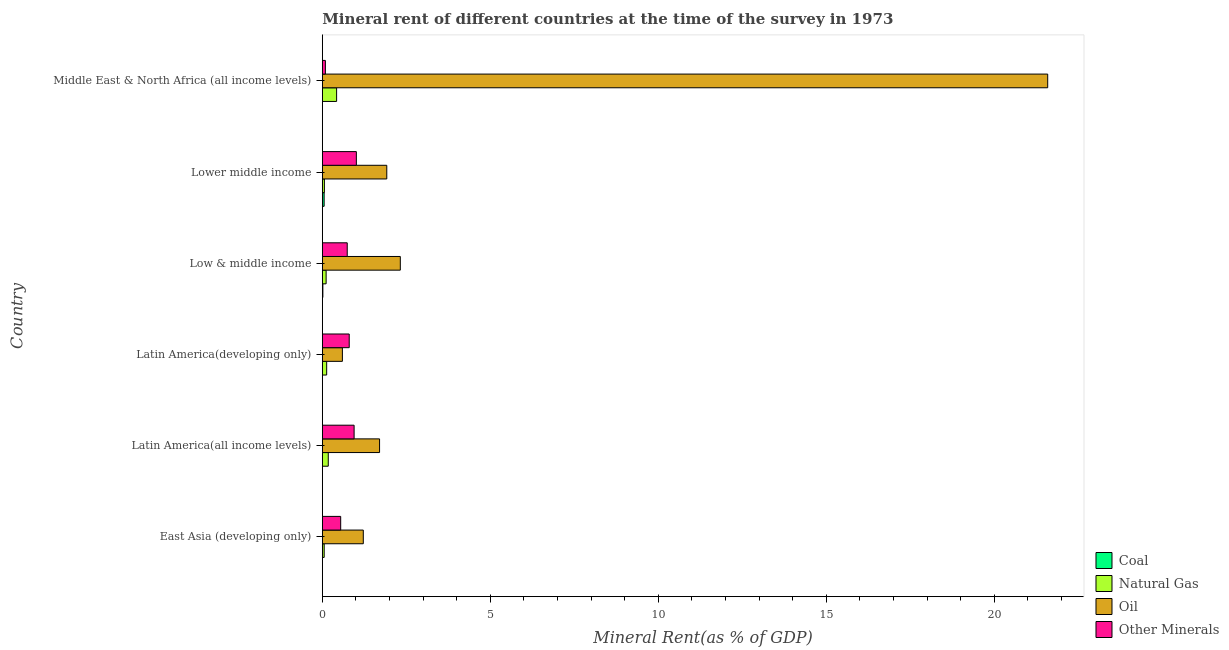How many different coloured bars are there?
Ensure brevity in your answer.  4. How many groups of bars are there?
Your answer should be very brief. 6. How many bars are there on the 3rd tick from the top?
Your response must be concise. 4. What is the label of the 5th group of bars from the top?
Provide a short and direct response. Latin America(all income levels). What is the natural gas rent in Low & middle income?
Your answer should be very brief. 0.11. Across all countries, what is the maximum coal rent?
Ensure brevity in your answer.  0.05. Across all countries, what is the minimum natural gas rent?
Your answer should be very brief. 0.06. In which country was the natural gas rent maximum?
Your answer should be very brief. Middle East & North Africa (all income levels). In which country was the  rent of other minerals minimum?
Offer a terse response. Middle East & North Africa (all income levels). What is the total oil rent in the graph?
Offer a very short reply. 29.35. What is the difference between the coal rent in Latin America(all income levels) and that in Low & middle income?
Offer a terse response. -0.02. What is the difference between the  rent of other minerals in Latin America(developing only) and the natural gas rent in Latin America(all income levels)?
Your answer should be very brief. 0.62. What is the average oil rent per country?
Your answer should be compact. 4.89. What is the difference between the coal rent and  rent of other minerals in Lower middle income?
Make the answer very short. -0.96. What is the ratio of the  rent of other minerals in East Asia (developing only) to that in Lower middle income?
Your answer should be compact. 0.54. Is the natural gas rent in Latin America(developing only) less than that in Lower middle income?
Offer a terse response. No. What is the difference between the highest and the second highest  rent of other minerals?
Keep it short and to the point. 0.07. What is the difference between the highest and the lowest oil rent?
Your answer should be compact. 20.99. Is the sum of the natural gas rent in Latin America(all income levels) and Middle East & North Africa (all income levels) greater than the maximum  rent of other minerals across all countries?
Your answer should be compact. No. Is it the case that in every country, the sum of the coal rent and natural gas rent is greater than the sum of  rent of other minerals and oil rent?
Your answer should be compact. No. What does the 3rd bar from the top in Middle East & North Africa (all income levels) represents?
Ensure brevity in your answer.  Natural Gas. What does the 2nd bar from the bottom in Low & middle income represents?
Provide a succinct answer. Natural Gas. Is it the case that in every country, the sum of the coal rent and natural gas rent is greater than the oil rent?
Give a very brief answer. No. How many bars are there?
Ensure brevity in your answer.  24. Are all the bars in the graph horizontal?
Make the answer very short. Yes. What is the difference between two consecutive major ticks on the X-axis?
Ensure brevity in your answer.  5. Does the graph contain any zero values?
Offer a terse response. No. Where does the legend appear in the graph?
Offer a very short reply. Bottom right. How many legend labels are there?
Offer a very short reply. 4. How are the legend labels stacked?
Offer a very short reply. Vertical. What is the title of the graph?
Offer a terse response. Mineral rent of different countries at the time of the survey in 1973. Does "Korea" appear as one of the legend labels in the graph?
Your answer should be very brief. No. What is the label or title of the X-axis?
Offer a terse response. Mineral Rent(as % of GDP). What is the Mineral Rent(as % of GDP) in Coal in East Asia (developing only)?
Offer a very short reply. 0. What is the Mineral Rent(as % of GDP) of Natural Gas in East Asia (developing only)?
Provide a short and direct response. 0.06. What is the Mineral Rent(as % of GDP) of Oil in East Asia (developing only)?
Your response must be concise. 1.22. What is the Mineral Rent(as % of GDP) in Other Minerals in East Asia (developing only)?
Give a very brief answer. 0.55. What is the Mineral Rent(as % of GDP) in Coal in Latin America(all income levels)?
Give a very brief answer. 1.897656593667769e-5. What is the Mineral Rent(as % of GDP) in Natural Gas in Latin America(all income levels)?
Make the answer very short. 0.18. What is the Mineral Rent(as % of GDP) of Oil in Latin America(all income levels)?
Ensure brevity in your answer.  1.7. What is the Mineral Rent(as % of GDP) in Other Minerals in Latin America(all income levels)?
Provide a short and direct response. 0.95. What is the Mineral Rent(as % of GDP) in Coal in Latin America(developing only)?
Offer a terse response. 2.93770621847752e-5. What is the Mineral Rent(as % of GDP) in Natural Gas in Latin America(developing only)?
Provide a short and direct response. 0.13. What is the Mineral Rent(as % of GDP) of Oil in Latin America(developing only)?
Your answer should be compact. 0.6. What is the Mineral Rent(as % of GDP) in Other Minerals in Latin America(developing only)?
Provide a succinct answer. 0.8. What is the Mineral Rent(as % of GDP) in Coal in Low & middle income?
Make the answer very short. 0.02. What is the Mineral Rent(as % of GDP) of Natural Gas in Low & middle income?
Your answer should be compact. 0.11. What is the Mineral Rent(as % of GDP) of Oil in Low & middle income?
Make the answer very short. 2.32. What is the Mineral Rent(as % of GDP) of Other Minerals in Low & middle income?
Ensure brevity in your answer.  0.74. What is the Mineral Rent(as % of GDP) of Coal in Lower middle income?
Provide a succinct answer. 0.05. What is the Mineral Rent(as % of GDP) of Natural Gas in Lower middle income?
Make the answer very short. 0.06. What is the Mineral Rent(as % of GDP) of Oil in Lower middle income?
Your answer should be compact. 1.92. What is the Mineral Rent(as % of GDP) in Other Minerals in Lower middle income?
Your answer should be very brief. 1.01. What is the Mineral Rent(as % of GDP) in Coal in Middle East & North Africa (all income levels)?
Make the answer very short. 0. What is the Mineral Rent(as % of GDP) in Natural Gas in Middle East & North Africa (all income levels)?
Ensure brevity in your answer.  0.43. What is the Mineral Rent(as % of GDP) in Oil in Middle East & North Africa (all income levels)?
Keep it short and to the point. 21.59. What is the Mineral Rent(as % of GDP) of Other Minerals in Middle East & North Africa (all income levels)?
Provide a succinct answer. 0.09. Across all countries, what is the maximum Mineral Rent(as % of GDP) in Coal?
Make the answer very short. 0.05. Across all countries, what is the maximum Mineral Rent(as % of GDP) in Natural Gas?
Your answer should be very brief. 0.43. Across all countries, what is the maximum Mineral Rent(as % of GDP) of Oil?
Offer a very short reply. 21.59. Across all countries, what is the maximum Mineral Rent(as % of GDP) of Other Minerals?
Your answer should be very brief. 1.01. Across all countries, what is the minimum Mineral Rent(as % of GDP) in Coal?
Offer a very short reply. 1.897656593667769e-5. Across all countries, what is the minimum Mineral Rent(as % of GDP) in Natural Gas?
Ensure brevity in your answer.  0.06. Across all countries, what is the minimum Mineral Rent(as % of GDP) in Oil?
Offer a very short reply. 0.6. Across all countries, what is the minimum Mineral Rent(as % of GDP) in Other Minerals?
Your answer should be very brief. 0.09. What is the total Mineral Rent(as % of GDP) of Coal in the graph?
Make the answer very short. 0.07. What is the total Mineral Rent(as % of GDP) of Natural Gas in the graph?
Offer a terse response. 0.96. What is the total Mineral Rent(as % of GDP) of Oil in the graph?
Your response must be concise. 29.35. What is the total Mineral Rent(as % of GDP) of Other Minerals in the graph?
Ensure brevity in your answer.  4.14. What is the difference between the Mineral Rent(as % of GDP) in Natural Gas in East Asia (developing only) and that in Latin America(all income levels)?
Your response must be concise. -0.12. What is the difference between the Mineral Rent(as % of GDP) in Oil in East Asia (developing only) and that in Latin America(all income levels)?
Your response must be concise. -0.48. What is the difference between the Mineral Rent(as % of GDP) in Other Minerals in East Asia (developing only) and that in Latin America(all income levels)?
Ensure brevity in your answer.  -0.4. What is the difference between the Mineral Rent(as % of GDP) of Coal in East Asia (developing only) and that in Latin America(developing only)?
Ensure brevity in your answer.  0. What is the difference between the Mineral Rent(as % of GDP) in Natural Gas in East Asia (developing only) and that in Latin America(developing only)?
Provide a succinct answer. -0.07. What is the difference between the Mineral Rent(as % of GDP) in Oil in East Asia (developing only) and that in Latin America(developing only)?
Your response must be concise. 0.62. What is the difference between the Mineral Rent(as % of GDP) in Other Minerals in East Asia (developing only) and that in Latin America(developing only)?
Offer a terse response. -0.25. What is the difference between the Mineral Rent(as % of GDP) of Coal in East Asia (developing only) and that in Low & middle income?
Make the answer very short. -0.02. What is the difference between the Mineral Rent(as % of GDP) in Natural Gas in East Asia (developing only) and that in Low & middle income?
Offer a terse response. -0.06. What is the difference between the Mineral Rent(as % of GDP) in Oil in East Asia (developing only) and that in Low & middle income?
Your response must be concise. -1.1. What is the difference between the Mineral Rent(as % of GDP) of Other Minerals in East Asia (developing only) and that in Low & middle income?
Your answer should be very brief. -0.19. What is the difference between the Mineral Rent(as % of GDP) of Coal in East Asia (developing only) and that in Lower middle income?
Your response must be concise. -0.05. What is the difference between the Mineral Rent(as % of GDP) of Natural Gas in East Asia (developing only) and that in Lower middle income?
Keep it short and to the point. -0.01. What is the difference between the Mineral Rent(as % of GDP) in Oil in East Asia (developing only) and that in Lower middle income?
Your answer should be compact. -0.7. What is the difference between the Mineral Rent(as % of GDP) in Other Minerals in East Asia (developing only) and that in Lower middle income?
Your answer should be compact. -0.47. What is the difference between the Mineral Rent(as % of GDP) of Coal in East Asia (developing only) and that in Middle East & North Africa (all income levels)?
Your response must be concise. -0. What is the difference between the Mineral Rent(as % of GDP) in Natural Gas in East Asia (developing only) and that in Middle East & North Africa (all income levels)?
Keep it short and to the point. -0.37. What is the difference between the Mineral Rent(as % of GDP) in Oil in East Asia (developing only) and that in Middle East & North Africa (all income levels)?
Offer a very short reply. -20.37. What is the difference between the Mineral Rent(as % of GDP) in Other Minerals in East Asia (developing only) and that in Middle East & North Africa (all income levels)?
Your response must be concise. 0.46. What is the difference between the Mineral Rent(as % of GDP) in Coal in Latin America(all income levels) and that in Latin America(developing only)?
Your response must be concise. -0. What is the difference between the Mineral Rent(as % of GDP) of Natural Gas in Latin America(all income levels) and that in Latin America(developing only)?
Give a very brief answer. 0.05. What is the difference between the Mineral Rent(as % of GDP) of Oil in Latin America(all income levels) and that in Latin America(developing only)?
Provide a succinct answer. 1.11. What is the difference between the Mineral Rent(as % of GDP) in Other Minerals in Latin America(all income levels) and that in Latin America(developing only)?
Ensure brevity in your answer.  0.15. What is the difference between the Mineral Rent(as % of GDP) in Coal in Latin America(all income levels) and that in Low & middle income?
Your answer should be compact. -0.02. What is the difference between the Mineral Rent(as % of GDP) in Natural Gas in Latin America(all income levels) and that in Low & middle income?
Ensure brevity in your answer.  0.06. What is the difference between the Mineral Rent(as % of GDP) of Oil in Latin America(all income levels) and that in Low & middle income?
Your answer should be compact. -0.62. What is the difference between the Mineral Rent(as % of GDP) in Other Minerals in Latin America(all income levels) and that in Low & middle income?
Offer a terse response. 0.2. What is the difference between the Mineral Rent(as % of GDP) of Coal in Latin America(all income levels) and that in Lower middle income?
Provide a short and direct response. -0.05. What is the difference between the Mineral Rent(as % of GDP) of Natural Gas in Latin America(all income levels) and that in Lower middle income?
Offer a very short reply. 0.12. What is the difference between the Mineral Rent(as % of GDP) of Oil in Latin America(all income levels) and that in Lower middle income?
Your response must be concise. -0.21. What is the difference between the Mineral Rent(as % of GDP) of Other Minerals in Latin America(all income levels) and that in Lower middle income?
Give a very brief answer. -0.07. What is the difference between the Mineral Rent(as % of GDP) of Coal in Latin America(all income levels) and that in Middle East & North Africa (all income levels)?
Offer a very short reply. -0. What is the difference between the Mineral Rent(as % of GDP) in Natural Gas in Latin America(all income levels) and that in Middle East & North Africa (all income levels)?
Ensure brevity in your answer.  -0.25. What is the difference between the Mineral Rent(as % of GDP) of Oil in Latin America(all income levels) and that in Middle East & North Africa (all income levels)?
Offer a very short reply. -19.89. What is the difference between the Mineral Rent(as % of GDP) in Other Minerals in Latin America(all income levels) and that in Middle East & North Africa (all income levels)?
Offer a terse response. 0.85. What is the difference between the Mineral Rent(as % of GDP) of Coal in Latin America(developing only) and that in Low & middle income?
Your response must be concise. -0.02. What is the difference between the Mineral Rent(as % of GDP) in Natural Gas in Latin America(developing only) and that in Low & middle income?
Offer a very short reply. 0.02. What is the difference between the Mineral Rent(as % of GDP) of Oil in Latin America(developing only) and that in Low & middle income?
Your answer should be very brief. -1.72. What is the difference between the Mineral Rent(as % of GDP) in Other Minerals in Latin America(developing only) and that in Low & middle income?
Give a very brief answer. 0.06. What is the difference between the Mineral Rent(as % of GDP) of Coal in Latin America(developing only) and that in Lower middle income?
Make the answer very short. -0.05. What is the difference between the Mineral Rent(as % of GDP) of Natural Gas in Latin America(developing only) and that in Lower middle income?
Your answer should be compact. 0.07. What is the difference between the Mineral Rent(as % of GDP) of Oil in Latin America(developing only) and that in Lower middle income?
Your answer should be very brief. -1.32. What is the difference between the Mineral Rent(as % of GDP) of Other Minerals in Latin America(developing only) and that in Lower middle income?
Offer a terse response. -0.21. What is the difference between the Mineral Rent(as % of GDP) in Coal in Latin America(developing only) and that in Middle East & North Africa (all income levels)?
Offer a terse response. -0. What is the difference between the Mineral Rent(as % of GDP) in Natural Gas in Latin America(developing only) and that in Middle East & North Africa (all income levels)?
Your response must be concise. -0.3. What is the difference between the Mineral Rent(as % of GDP) in Oil in Latin America(developing only) and that in Middle East & North Africa (all income levels)?
Keep it short and to the point. -20.99. What is the difference between the Mineral Rent(as % of GDP) of Other Minerals in Latin America(developing only) and that in Middle East & North Africa (all income levels)?
Offer a terse response. 0.71. What is the difference between the Mineral Rent(as % of GDP) of Coal in Low & middle income and that in Lower middle income?
Make the answer very short. -0.04. What is the difference between the Mineral Rent(as % of GDP) of Natural Gas in Low & middle income and that in Lower middle income?
Offer a very short reply. 0.05. What is the difference between the Mineral Rent(as % of GDP) in Oil in Low & middle income and that in Lower middle income?
Your response must be concise. 0.4. What is the difference between the Mineral Rent(as % of GDP) of Other Minerals in Low & middle income and that in Lower middle income?
Provide a short and direct response. -0.27. What is the difference between the Mineral Rent(as % of GDP) in Coal in Low & middle income and that in Middle East & North Africa (all income levels)?
Keep it short and to the point. 0.01. What is the difference between the Mineral Rent(as % of GDP) of Natural Gas in Low & middle income and that in Middle East & North Africa (all income levels)?
Provide a succinct answer. -0.31. What is the difference between the Mineral Rent(as % of GDP) of Oil in Low & middle income and that in Middle East & North Africa (all income levels)?
Ensure brevity in your answer.  -19.27. What is the difference between the Mineral Rent(as % of GDP) of Other Minerals in Low & middle income and that in Middle East & North Africa (all income levels)?
Ensure brevity in your answer.  0.65. What is the difference between the Mineral Rent(as % of GDP) of Coal in Lower middle income and that in Middle East & North Africa (all income levels)?
Your answer should be very brief. 0.05. What is the difference between the Mineral Rent(as % of GDP) in Natural Gas in Lower middle income and that in Middle East & North Africa (all income levels)?
Your response must be concise. -0.36. What is the difference between the Mineral Rent(as % of GDP) of Oil in Lower middle income and that in Middle East & North Africa (all income levels)?
Offer a terse response. -19.67. What is the difference between the Mineral Rent(as % of GDP) in Other Minerals in Lower middle income and that in Middle East & North Africa (all income levels)?
Offer a very short reply. 0.92. What is the difference between the Mineral Rent(as % of GDP) in Coal in East Asia (developing only) and the Mineral Rent(as % of GDP) in Natural Gas in Latin America(all income levels)?
Keep it short and to the point. -0.18. What is the difference between the Mineral Rent(as % of GDP) in Coal in East Asia (developing only) and the Mineral Rent(as % of GDP) in Oil in Latin America(all income levels)?
Make the answer very short. -1.7. What is the difference between the Mineral Rent(as % of GDP) in Coal in East Asia (developing only) and the Mineral Rent(as % of GDP) in Other Minerals in Latin America(all income levels)?
Give a very brief answer. -0.95. What is the difference between the Mineral Rent(as % of GDP) in Natural Gas in East Asia (developing only) and the Mineral Rent(as % of GDP) in Oil in Latin America(all income levels)?
Make the answer very short. -1.65. What is the difference between the Mineral Rent(as % of GDP) of Natural Gas in East Asia (developing only) and the Mineral Rent(as % of GDP) of Other Minerals in Latin America(all income levels)?
Offer a very short reply. -0.89. What is the difference between the Mineral Rent(as % of GDP) of Oil in East Asia (developing only) and the Mineral Rent(as % of GDP) of Other Minerals in Latin America(all income levels)?
Give a very brief answer. 0.27. What is the difference between the Mineral Rent(as % of GDP) in Coal in East Asia (developing only) and the Mineral Rent(as % of GDP) in Natural Gas in Latin America(developing only)?
Give a very brief answer. -0.13. What is the difference between the Mineral Rent(as % of GDP) of Coal in East Asia (developing only) and the Mineral Rent(as % of GDP) of Oil in Latin America(developing only)?
Keep it short and to the point. -0.6. What is the difference between the Mineral Rent(as % of GDP) in Coal in East Asia (developing only) and the Mineral Rent(as % of GDP) in Other Minerals in Latin America(developing only)?
Provide a succinct answer. -0.8. What is the difference between the Mineral Rent(as % of GDP) in Natural Gas in East Asia (developing only) and the Mineral Rent(as % of GDP) in Oil in Latin America(developing only)?
Offer a very short reply. -0.54. What is the difference between the Mineral Rent(as % of GDP) of Natural Gas in East Asia (developing only) and the Mineral Rent(as % of GDP) of Other Minerals in Latin America(developing only)?
Your answer should be compact. -0.74. What is the difference between the Mineral Rent(as % of GDP) in Oil in East Asia (developing only) and the Mineral Rent(as % of GDP) in Other Minerals in Latin America(developing only)?
Keep it short and to the point. 0.42. What is the difference between the Mineral Rent(as % of GDP) of Coal in East Asia (developing only) and the Mineral Rent(as % of GDP) of Natural Gas in Low & middle income?
Your answer should be very brief. -0.11. What is the difference between the Mineral Rent(as % of GDP) in Coal in East Asia (developing only) and the Mineral Rent(as % of GDP) in Oil in Low & middle income?
Provide a succinct answer. -2.32. What is the difference between the Mineral Rent(as % of GDP) of Coal in East Asia (developing only) and the Mineral Rent(as % of GDP) of Other Minerals in Low & middle income?
Ensure brevity in your answer.  -0.74. What is the difference between the Mineral Rent(as % of GDP) in Natural Gas in East Asia (developing only) and the Mineral Rent(as % of GDP) in Oil in Low & middle income?
Give a very brief answer. -2.27. What is the difference between the Mineral Rent(as % of GDP) of Natural Gas in East Asia (developing only) and the Mineral Rent(as % of GDP) of Other Minerals in Low & middle income?
Provide a short and direct response. -0.69. What is the difference between the Mineral Rent(as % of GDP) in Oil in East Asia (developing only) and the Mineral Rent(as % of GDP) in Other Minerals in Low & middle income?
Your answer should be compact. 0.48. What is the difference between the Mineral Rent(as % of GDP) of Coal in East Asia (developing only) and the Mineral Rent(as % of GDP) of Natural Gas in Lower middle income?
Your answer should be compact. -0.06. What is the difference between the Mineral Rent(as % of GDP) of Coal in East Asia (developing only) and the Mineral Rent(as % of GDP) of Oil in Lower middle income?
Your answer should be compact. -1.92. What is the difference between the Mineral Rent(as % of GDP) in Coal in East Asia (developing only) and the Mineral Rent(as % of GDP) in Other Minerals in Lower middle income?
Offer a terse response. -1.01. What is the difference between the Mineral Rent(as % of GDP) of Natural Gas in East Asia (developing only) and the Mineral Rent(as % of GDP) of Oil in Lower middle income?
Offer a terse response. -1.86. What is the difference between the Mineral Rent(as % of GDP) in Natural Gas in East Asia (developing only) and the Mineral Rent(as % of GDP) in Other Minerals in Lower middle income?
Provide a succinct answer. -0.96. What is the difference between the Mineral Rent(as % of GDP) of Oil in East Asia (developing only) and the Mineral Rent(as % of GDP) of Other Minerals in Lower middle income?
Your answer should be very brief. 0.21. What is the difference between the Mineral Rent(as % of GDP) of Coal in East Asia (developing only) and the Mineral Rent(as % of GDP) of Natural Gas in Middle East & North Africa (all income levels)?
Give a very brief answer. -0.42. What is the difference between the Mineral Rent(as % of GDP) of Coal in East Asia (developing only) and the Mineral Rent(as % of GDP) of Oil in Middle East & North Africa (all income levels)?
Provide a short and direct response. -21.59. What is the difference between the Mineral Rent(as % of GDP) in Coal in East Asia (developing only) and the Mineral Rent(as % of GDP) in Other Minerals in Middle East & North Africa (all income levels)?
Your answer should be compact. -0.09. What is the difference between the Mineral Rent(as % of GDP) of Natural Gas in East Asia (developing only) and the Mineral Rent(as % of GDP) of Oil in Middle East & North Africa (all income levels)?
Keep it short and to the point. -21.53. What is the difference between the Mineral Rent(as % of GDP) of Natural Gas in East Asia (developing only) and the Mineral Rent(as % of GDP) of Other Minerals in Middle East & North Africa (all income levels)?
Provide a short and direct response. -0.04. What is the difference between the Mineral Rent(as % of GDP) in Oil in East Asia (developing only) and the Mineral Rent(as % of GDP) in Other Minerals in Middle East & North Africa (all income levels)?
Provide a succinct answer. 1.13. What is the difference between the Mineral Rent(as % of GDP) in Coal in Latin America(all income levels) and the Mineral Rent(as % of GDP) in Natural Gas in Latin America(developing only)?
Give a very brief answer. -0.13. What is the difference between the Mineral Rent(as % of GDP) of Coal in Latin America(all income levels) and the Mineral Rent(as % of GDP) of Oil in Latin America(developing only)?
Offer a very short reply. -0.6. What is the difference between the Mineral Rent(as % of GDP) in Coal in Latin America(all income levels) and the Mineral Rent(as % of GDP) in Other Minerals in Latin America(developing only)?
Make the answer very short. -0.8. What is the difference between the Mineral Rent(as % of GDP) of Natural Gas in Latin America(all income levels) and the Mineral Rent(as % of GDP) of Oil in Latin America(developing only)?
Your response must be concise. -0.42. What is the difference between the Mineral Rent(as % of GDP) of Natural Gas in Latin America(all income levels) and the Mineral Rent(as % of GDP) of Other Minerals in Latin America(developing only)?
Offer a very short reply. -0.62. What is the difference between the Mineral Rent(as % of GDP) of Oil in Latin America(all income levels) and the Mineral Rent(as % of GDP) of Other Minerals in Latin America(developing only)?
Offer a very short reply. 0.9. What is the difference between the Mineral Rent(as % of GDP) in Coal in Latin America(all income levels) and the Mineral Rent(as % of GDP) in Natural Gas in Low & middle income?
Offer a terse response. -0.11. What is the difference between the Mineral Rent(as % of GDP) of Coal in Latin America(all income levels) and the Mineral Rent(as % of GDP) of Oil in Low & middle income?
Provide a short and direct response. -2.32. What is the difference between the Mineral Rent(as % of GDP) in Coal in Latin America(all income levels) and the Mineral Rent(as % of GDP) in Other Minerals in Low & middle income?
Make the answer very short. -0.74. What is the difference between the Mineral Rent(as % of GDP) of Natural Gas in Latin America(all income levels) and the Mineral Rent(as % of GDP) of Oil in Low & middle income?
Keep it short and to the point. -2.14. What is the difference between the Mineral Rent(as % of GDP) of Natural Gas in Latin America(all income levels) and the Mineral Rent(as % of GDP) of Other Minerals in Low & middle income?
Offer a very short reply. -0.56. What is the difference between the Mineral Rent(as % of GDP) in Oil in Latin America(all income levels) and the Mineral Rent(as % of GDP) in Other Minerals in Low & middle income?
Your answer should be very brief. 0.96. What is the difference between the Mineral Rent(as % of GDP) of Coal in Latin America(all income levels) and the Mineral Rent(as % of GDP) of Natural Gas in Lower middle income?
Offer a terse response. -0.06. What is the difference between the Mineral Rent(as % of GDP) of Coal in Latin America(all income levels) and the Mineral Rent(as % of GDP) of Oil in Lower middle income?
Keep it short and to the point. -1.92. What is the difference between the Mineral Rent(as % of GDP) in Coal in Latin America(all income levels) and the Mineral Rent(as % of GDP) in Other Minerals in Lower middle income?
Keep it short and to the point. -1.01. What is the difference between the Mineral Rent(as % of GDP) of Natural Gas in Latin America(all income levels) and the Mineral Rent(as % of GDP) of Oil in Lower middle income?
Provide a succinct answer. -1.74. What is the difference between the Mineral Rent(as % of GDP) in Natural Gas in Latin America(all income levels) and the Mineral Rent(as % of GDP) in Other Minerals in Lower middle income?
Offer a very short reply. -0.84. What is the difference between the Mineral Rent(as % of GDP) of Oil in Latin America(all income levels) and the Mineral Rent(as % of GDP) of Other Minerals in Lower middle income?
Your answer should be compact. 0.69. What is the difference between the Mineral Rent(as % of GDP) in Coal in Latin America(all income levels) and the Mineral Rent(as % of GDP) in Natural Gas in Middle East & North Africa (all income levels)?
Offer a terse response. -0.42. What is the difference between the Mineral Rent(as % of GDP) in Coal in Latin America(all income levels) and the Mineral Rent(as % of GDP) in Oil in Middle East & North Africa (all income levels)?
Offer a terse response. -21.59. What is the difference between the Mineral Rent(as % of GDP) in Coal in Latin America(all income levels) and the Mineral Rent(as % of GDP) in Other Minerals in Middle East & North Africa (all income levels)?
Your answer should be compact. -0.09. What is the difference between the Mineral Rent(as % of GDP) of Natural Gas in Latin America(all income levels) and the Mineral Rent(as % of GDP) of Oil in Middle East & North Africa (all income levels)?
Provide a short and direct response. -21.41. What is the difference between the Mineral Rent(as % of GDP) in Natural Gas in Latin America(all income levels) and the Mineral Rent(as % of GDP) in Other Minerals in Middle East & North Africa (all income levels)?
Make the answer very short. 0.09. What is the difference between the Mineral Rent(as % of GDP) of Oil in Latin America(all income levels) and the Mineral Rent(as % of GDP) of Other Minerals in Middle East & North Africa (all income levels)?
Make the answer very short. 1.61. What is the difference between the Mineral Rent(as % of GDP) of Coal in Latin America(developing only) and the Mineral Rent(as % of GDP) of Natural Gas in Low & middle income?
Your response must be concise. -0.11. What is the difference between the Mineral Rent(as % of GDP) in Coal in Latin America(developing only) and the Mineral Rent(as % of GDP) in Oil in Low & middle income?
Offer a terse response. -2.32. What is the difference between the Mineral Rent(as % of GDP) in Coal in Latin America(developing only) and the Mineral Rent(as % of GDP) in Other Minerals in Low & middle income?
Provide a succinct answer. -0.74. What is the difference between the Mineral Rent(as % of GDP) of Natural Gas in Latin America(developing only) and the Mineral Rent(as % of GDP) of Oil in Low & middle income?
Keep it short and to the point. -2.19. What is the difference between the Mineral Rent(as % of GDP) of Natural Gas in Latin America(developing only) and the Mineral Rent(as % of GDP) of Other Minerals in Low & middle income?
Your answer should be very brief. -0.61. What is the difference between the Mineral Rent(as % of GDP) in Oil in Latin America(developing only) and the Mineral Rent(as % of GDP) in Other Minerals in Low & middle income?
Provide a succinct answer. -0.14. What is the difference between the Mineral Rent(as % of GDP) of Coal in Latin America(developing only) and the Mineral Rent(as % of GDP) of Natural Gas in Lower middle income?
Ensure brevity in your answer.  -0.06. What is the difference between the Mineral Rent(as % of GDP) of Coal in Latin America(developing only) and the Mineral Rent(as % of GDP) of Oil in Lower middle income?
Your answer should be compact. -1.92. What is the difference between the Mineral Rent(as % of GDP) of Coal in Latin America(developing only) and the Mineral Rent(as % of GDP) of Other Minerals in Lower middle income?
Make the answer very short. -1.01. What is the difference between the Mineral Rent(as % of GDP) in Natural Gas in Latin America(developing only) and the Mineral Rent(as % of GDP) in Oil in Lower middle income?
Your answer should be very brief. -1.79. What is the difference between the Mineral Rent(as % of GDP) in Natural Gas in Latin America(developing only) and the Mineral Rent(as % of GDP) in Other Minerals in Lower middle income?
Give a very brief answer. -0.88. What is the difference between the Mineral Rent(as % of GDP) in Oil in Latin America(developing only) and the Mineral Rent(as % of GDP) in Other Minerals in Lower middle income?
Make the answer very short. -0.42. What is the difference between the Mineral Rent(as % of GDP) in Coal in Latin America(developing only) and the Mineral Rent(as % of GDP) in Natural Gas in Middle East & North Africa (all income levels)?
Keep it short and to the point. -0.42. What is the difference between the Mineral Rent(as % of GDP) of Coal in Latin America(developing only) and the Mineral Rent(as % of GDP) of Oil in Middle East & North Africa (all income levels)?
Provide a short and direct response. -21.59. What is the difference between the Mineral Rent(as % of GDP) in Coal in Latin America(developing only) and the Mineral Rent(as % of GDP) in Other Minerals in Middle East & North Africa (all income levels)?
Your response must be concise. -0.09. What is the difference between the Mineral Rent(as % of GDP) of Natural Gas in Latin America(developing only) and the Mineral Rent(as % of GDP) of Oil in Middle East & North Africa (all income levels)?
Your answer should be very brief. -21.46. What is the difference between the Mineral Rent(as % of GDP) in Natural Gas in Latin America(developing only) and the Mineral Rent(as % of GDP) in Other Minerals in Middle East & North Africa (all income levels)?
Your answer should be compact. 0.04. What is the difference between the Mineral Rent(as % of GDP) in Oil in Latin America(developing only) and the Mineral Rent(as % of GDP) in Other Minerals in Middle East & North Africa (all income levels)?
Your answer should be compact. 0.51. What is the difference between the Mineral Rent(as % of GDP) in Coal in Low & middle income and the Mineral Rent(as % of GDP) in Natural Gas in Lower middle income?
Ensure brevity in your answer.  -0.05. What is the difference between the Mineral Rent(as % of GDP) in Coal in Low & middle income and the Mineral Rent(as % of GDP) in Oil in Lower middle income?
Your answer should be very brief. -1.9. What is the difference between the Mineral Rent(as % of GDP) of Coal in Low & middle income and the Mineral Rent(as % of GDP) of Other Minerals in Lower middle income?
Keep it short and to the point. -1. What is the difference between the Mineral Rent(as % of GDP) in Natural Gas in Low & middle income and the Mineral Rent(as % of GDP) in Oil in Lower middle income?
Ensure brevity in your answer.  -1.81. What is the difference between the Mineral Rent(as % of GDP) in Natural Gas in Low & middle income and the Mineral Rent(as % of GDP) in Other Minerals in Lower middle income?
Provide a short and direct response. -0.9. What is the difference between the Mineral Rent(as % of GDP) in Oil in Low & middle income and the Mineral Rent(as % of GDP) in Other Minerals in Lower middle income?
Ensure brevity in your answer.  1.31. What is the difference between the Mineral Rent(as % of GDP) in Coal in Low & middle income and the Mineral Rent(as % of GDP) in Natural Gas in Middle East & North Africa (all income levels)?
Keep it short and to the point. -0.41. What is the difference between the Mineral Rent(as % of GDP) in Coal in Low & middle income and the Mineral Rent(as % of GDP) in Oil in Middle East & North Africa (all income levels)?
Keep it short and to the point. -21.57. What is the difference between the Mineral Rent(as % of GDP) in Coal in Low & middle income and the Mineral Rent(as % of GDP) in Other Minerals in Middle East & North Africa (all income levels)?
Offer a terse response. -0.07. What is the difference between the Mineral Rent(as % of GDP) of Natural Gas in Low & middle income and the Mineral Rent(as % of GDP) of Oil in Middle East & North Africa (all income levels)?
Provide a short and direct response. -21.48. What is the difference between the Mineral Rent(as % of GDP) in Natural Gas in Low & middle income and the Mineral Rent(as % of GDP) in Other Minerals in Middle East & North Africa (all income levels)?
Offer a terse response. 0.02. What is the difference between the Mineral Rent(as % of GDP) of Oil in Low & middle income and the Mineral Rent(as % of GDP) of Other Minerals in Middle East & North Africa (all income levels)?
Offer a terse response. 2.23. What is the difference between the Mineral Rent(as % of GDP) in Coal in Lower middle income and the Mineral Rent(as % of GDP) in Natural Gas in Middle East & North Africa (all income levels)?
Your answer should be compact. -0.37. What is the difference between the Mineral Rent(as % of GDP) of Coal in Lower middle income and the Mineral Rent(as % of GDP) of Oil in Middle East & North Africa (all income levels)?
Keep it short and to the point. -21.54. What is the difference between the Mineral Rent(as % of GDP) of Coal in Lower middle income and the Mineral Rent(as % of GDP) of Other Minerals in Middle East & North Africa (all income levels)?
Keep it short and to the point. -0.04. What is the difference between the Mineral Rent(as % of GDP) of Natural Gas in Lower middle income and the Mineral Rent(as % of GDP) of Oil in Middle East & North Africa (all income levels)?
Keep it short and to the point. -21.53. What is the difference between the Mineral Rent(as % of GDP) in Natural Gas in Lower middle income and the Mineral Rent(as % of GDP) in Other Minerals in Middle East & North Africa (all income levels)?
Give a very brief answer. -0.03. What is the difference between the Mineral Rent(as % of GDP) of Oil in Lower middle income and the Mineral Rent(as % of GDP) of Other Minerals in Middle East & North Africa (all income levels)?
Your response must be concise. 1.83. What is the average Mineral Rent(as % of GDP) in Coal per country?
Offer a very short reply. 0.01. What is the average Mineral Rent(as % of GDP) of Natural Gas per country?
Offer a very short reply. 0.16. What is the average Mineral Rent(as % of GDP) of Oil per country?
Your answer should be compact. 4.89. What is the average Mineral Rent(as % of GDP) of Other Minerals per country?
Provide a short and direct response. 0.69. What is the difference between the Mineral Rent(as % of GDP) of Coal and Mineral Rent(as % of GDP) of Natural Gas in East Asia (developing only)?
Your answer should be very brief. -0.06. What is the difference between the Mineral Rent(as % of GDP) of Coal and Mineral Rent(as % of GDP) of Oil in East Asia (developing only)?
Keep it short and to the point. -1.22. What is the difference between the Mineral Rent(as % of GDP) in Coal and Mineral Rent(as % of GDP) in Other Minerals in East Asia (developing only)?
Make the answer very short. -0.55. What is the difference between the Mineral Rent(as % of GDP) in Natural Gas and Mineral Rent(as % of GDP) in Oil in East Asia (developing only)?
Your response must be concise. -1.16. What is the difference between the Mineral Rent(as % of GDP) in Natural Gas and Mineral Rent(as % of GDP) in Other Minerals in East Asia (developing only)?
Keep it short and to the point. -0.49. What is the difference between the Mineral Rent(as % of GDP) of Oil and Mineral Rent(as % of GDP) of Other Minerals in East Asia (developing only)?
Provide a succinct answer. 0.67. What is the difference between the Mineral Rent(as % of GDP) in Coal and Mineral Rent(as % of GDP) in Natural Gas in Latin America(all income levels)?
Provide a short and direct response. -0.18. What is the difference between the Mineral Rent(as % of GDP) in Coal and Mineral Rent(as % of GDP) in Oil in Latin America(all income levels)?
Provide a short and direct response. -1.7. What is the difference between the Mineral Rent(as % of GDP) in Coal and Mineral Rent(as % of GDP) in Other Minerals in Latin America(all income levels)?
Give a very brief answer. -0.95. What is the difference between the Mineral Rent(as % of GDP) in Natural Gas and Mineral Rent(as % of GDP) in Oil in Latin America(all income levels)?
Your answer should be compact. -1.53. What is the difference between the Mineral Rent(as % of GDP) in Natural Gas and Mineral Rent(as % of GDP) in Other Minerals in Latin America(all income levels)?
Provide a succinct answer. -0.77. What is the difference between the Mineral Rent(as % of GDP) in Oil and Mineral Rent(as % of GDP) in Other Minerals in Latin America(all income levels)?
Keep it short and to the point. 0.76. What is the difference between the Mineral Rent(as % of GDP) of Coal and Mineral Rent(as % of GDP) of Natural Gas in Latin America(developing only)?
Offer a terse response. -0.13. What is the difference between the Mineral Rent(as % of GDP) in Coal and Mineral Rent(as % of GDP) in Oil in Latin America(developing only)?
Provide a succinct answer. -0.6. What is the difference between the Mineral Rent(as % of GDP) in Coal and Mineral Rent(as % of GDP) in Other Minerals in Latin America(developing only)?
Keep it short and to the point. -0.8. What is the difference between the Mineral Rent(as % of GDP) of Natural Gas and Mineral Rent(as % of GDP) of Oil in Latin America(developing only)?
Provide a succinct answer. -0.47. What is the difference between the Mineral Rent(as % of GDP) in Natural Gas and Mineral Rent(as % of GDP) in Other Minerals in Latin America(developing only)?
Your answer should be very brief. -0.67. What is the difference between the Mineral Rent(as % of GDP) of Oil and Mineral Rent(as % of GDP) of Other Minerals in Latin America(developing only)?
Offer a terse response. -0.2. What is the difference between the Mineral Rent(as % of GDP) of Coal and Mineral Rent(as % of GDP) of Natural Gas in Low & middle income?
Offer a terse response. -0.1. What is the difference between the Mineral Rent(as % of GDP) in Coal and Mineral Rent(as % of GDP) in Oil in Low & middle income?
Your answer should be compact. -2.31. What is the difference between the Mineral Rent(as % of GDP) of Coal and Mineral Rent(as % of GDP) of Other Minerals in Low & middle income?
Keep it short and to the point. -0.73. What is the difference between the Mineral Rent(as % of GDP) in Natural Gas and Mineral Rent(as % of GDP) in Oil in Low & middle income?
Your answer should be compact. -2.21. What is the difference between the Mineral Rent(as % of GDP) in Natural Gas and Mineral Rent(as % of GDP) in Other Minerals in Low & middle income?
Give a very brief answer. -0.63. What is the difference between the Mineral Rent(as % of GDP) in Oil and Mineral Rent(as % of GDP) in Other Minerals in Low & middle income?
Your answer should be compact. 1.58. What is the difference between the Mineral Rent(as % of GDP) of Coal and Mineral Rent(as % of GDP) of Natural Gas in Lower middle income?
Your response must be concise. -0.01. What is the difference between the Mineral Rent(as % of GDP) of Coal and Mineral Rent(as % of GDP) of Oil in Lower middle income?
Ensure brevity in your answer.  -1.86. What is the difference between the Mineral Rent(as % of GDP) of Coal and Mineral Rent(as % of GDP) of Other Minerals in Lower middle income?
Your answer should be compact. -0.96. What is the difference between the Mineral Rent(as % of GDP) of Natural Gas and Mineral Rent(as % of GDP) of Oil in Lower middle income?
Make the answer very short. -1.86. What is the difference between the Mineral Rent(as % of GDP) of Natural Gas and Mineral Rent(as % of GDP) of Other Minerals in Lower middle income?
Ensure brevity in your answer.  -0.95. What is the difference between the Mineral Rent(as % of GDP) in Oil and Mineral Rent(as % of GDP) in Other Minerals in Lower middle income?
Keep it short and to the point. 0.91. What is the difference between the Mineral Rent(as % of GDP) of Coal and Mineral Rent(as % of GDP) of Natural Gas in Middle East & North Africa (all income levels)?
Provide a succinct answer. -0.42. What is the difference between the Mineral Rent(as % of GDP) of Coal and Mineral Rent(as % of GDP) of Oil in Middle East & North Africa (all income levels)?
Offer a very short reply. -21.59. What is the difference between the Mineral Rent(as % of GDP) of Coal and Mineral Rent(as % of GDP) of Other Minerals in Middle East & North Africa (all income levels)?
Provide a succinct answer. -0.09. What is the difference between the Mineral Rent(as % of GDP) in Natural Gas and Mineral Rent(as % of GDP) in Oil in Middle East & North Africa (all income levels)?
Your answer should be very brief. -21.17. What is the difference between the Mineral Rent(as % of GDP) in Natural Gas and Mineral Rent(as % of GDP) in Other Minerals in Middle East & North Africa (all income levels)?
Your response must be concise. 0.33. What is the difference between the Mineral Rent(as % of GDP) of Oil and Mineral Rent(as % of GDP) of Other Minerals in Middle East & North Africa (all income levels)?
Offer a terse response. 21.5. What is the ratio of the Mineral Rent(as % of GDP) of Coal in East Asia (developing only) to that in Latin America(all income levels)?
Provide a succinct answer. 5.45. What is the ratio of the Mineral Rent(as % of GDP) of Natural Gas in East Asia (developing only) to that in Latin America(all income levels)?
Ensure brevity in your answer.  0.31. What is the ratio of the Mineral Rent(as % of GDP) of Oil in East Asia (developing only) to that in Latin America(all income levels)?
Offer a terse response. 0.72. What is the ratio of the Mineral Rent(as % of GDP) in Other Minerals in East Asia (developing only) to that in Latin America(all income levels)?
Provide a short and direct response. 0.58. What is the ratio of the Mineral Rent(as % of GDP) in Coal in East Asia (developing only) to that in Latin America(developing only)?
Ensure brevity in your answer.  3.52. What is the ratio of the Mineral Rent(as % of GDP) in Natural Gas in East Asia (developing only) to that in Latin America(developing only)?
Your response must be concise. 0.43. What is the ratio of the Mineral Rent(as % of GDP) in Oil in East Asia (developing only) to that in Latin America(developing only)?
Your answer should be compact. 2.04. What is the ratio of the Mineral Rent(as % of GDP) in Other Minerals in East Asia (developing only) to that in Latin America(developing only)?
Your response must be concise. 0.68. What is the ratio of the Mineral Rent(as % of GDP) in Coal in East Asia (developing only) to that in Low & middle income?
Provide a succinct answer. 0.01. What is the ratio of the Mineral Rent(as % of GDP) of Natural Gas in East Asia (developing only) to that in Low & middle income?
Ensure brevity in your answer.  0.49. What is the ratio of the Mineral Rent(as % of GDP) of Oil in East Asia (developing only) to that in Low & middle income?
Provide a succinct answer. 0.53. What is the ratio of the Mineral Rent(as % of GDP) of Other Minerals in East Asia (developing only) to that in Low & middle income?
Your answer should be compact. 0.74. What is the ratio of the Mineral Rent(as % of GDP) of Coal in East Asia (developing only) to that in Lower middle income?
Your answer should be compact. 0. What is the ratio of the Mineral Rent(as % of GDP) in Natural Gas in East Asia (developing only) to that in Lower middle income?
Offer a terse response. 0.91. What is the ratio of the Mineral Rent(as % of GDP) in Oil in East Asia (developing only) to that in Lower middle income?
Provide a succinct answer. 0.64. What is the ratio of the Mineral Rent(as % of GDP) in Other Minerals in East Asia (developing only) to that in Lower middle income?
Give a very brief answer. 0.54. What is the ratio of the Mineral Rent(as % of GDP) in Coal in East Asia (developing only) to that in Middle East & North Africa (all income levels)?
Ensure brevity in your answer.  0.06. What is the ratio of the Mineral Rent(as % of GDP) of Natural Gas in East Asia (developing only) to that in Middle East & North Africa (all income levels)?
Provide a short and direct response. 0.13. What is the ratio of the Mineral Rent(as % of GDP) of Oil in East Asia (developing only) to that in Middle East & North Africa (all income levels)?
Give a very brief answer. 0.06. What is the ratio of the Mineral Rent(as % of GDP) in Other Minerals in East Asia (developing only) to that in Middle East & North Africa (all income levels)?
Your answer should be compact. 6. What is the ratio of the Mineral Rent(as % of GDP) in Coal in Latin America(all income levels) to that in Latin America(developing only)?
Your answer should be very brief. 0.65. What is the ratio of the Mineral Rent(as % of GDP) in Natural Gas in Latin America(all income levels) to that in Latin America(developing only)?
Your response must be concise. 1.37. What is the ratio of the Mineral Rent(as % of GDP) in Oil in Latin America(all income levels) to that in Latin America(developing only)?
Your answer should be very brief. 2.85. What is the ratio of the Mineral Rent(as % of GDP) in Other Minerals in Latin America(all income levels) to that in Latin America(developing only)?
Offer a very short reply. 1.18. What is the ratio of the Mineral Rent(as % of GDP) of Coal in Latin America(all income levels) to that in Low & middle income?
Offer a very short reply. 0. What is the ratio of the Mineral Rent(as % of GDP) of Natural Gas in Latin America(all income levels) to that in Low & middle income?
Your answer should be very brief. 1.57. What is the ratio of the Mineral Rent(as % of GDP) in Oil in Latin America(all income levels) to that in Low & middle income?
Offer a terse response. 0.73. What is the ratio of the Mineral Rent(as % of GDP) of Other Minerals in Latin America(all income levels) to that in Low & middle income?
Offer a very short reply. 1.28. What is the ratio of the Mineral Rent(as % of GDP) in Natural Gas in Latin America(all income levels) to that in Lower middle income?
Your response must be concise. 2.88. What is the ratio of the Mineral Rent(as % of GDP) in Oil in Latin America(all income levels) to that in Lower middle income?
Keep it short and to the point. 0.89. What is the ratio of the Mineral Rent(as % of GDP) of Other Minerals in Latin America(all income levels) to that in Lower middle income?
Your response must be concise. 0.93. What is the ratio of the Mineral Rent(as % of GDP) in Coal in Latin America(all income levels) to that in Middle East & North Africa (all income levels)?
Your response must be concise. 0.01. What is the ratio of the Mineral Rent(as % of GDP) of Natural Gas in Latin America(all income levels) to that in Middle East & North Africa (all income levels)?
Give a very brief answer. 0.42. What is the ratio of the Mineral Rent(as % of GDP) in Oil in Latin America(all income levels) to that in Middle East & North Africa (all income levels)?
Ensure brevity in your answer.  0.08. What is the ratio of the Mineral Rent(as % of GDP) of Other Minerals in Latin America(all income levels) to that in Middle East & North Africa (all income levels)?
Offer a very short reply. 10.39. What is the ratio of the Mineral Rent(as % of GDP) in Coal in Latin America(developing only) to that in Low & middle income?
Make the answer very short. 0. What is the ratio of the Mineral Rent(as % of GDP) in Natural Gas in Latin America(developing only) to that in Low & middle income?
Give a very brief answer. 1.15. What is the ratio of the Mineral Rent(as % of GDP) in Oil in Latin America(developing only) to that in Low & middle income?
Make the answer very short. 0.26. What is the ratio of the Mineral Rent(as % of GDP) in Other Minerals in Latin America(developing only) to that in Low & middle income?
Make the answer very short. 1.08. What is the ratio of the Mineral Rent(as % of GDP) of Coal in Latin America(developing only) to that in Lower middle income?
Keep it short and to the point. 0. What is the ratio of the Mineral Rent(as % of GDP) in Natural Gas in Latin America(developing only) to that in Lower middle income?
Ensure brevity in your answer.  2.11. What is the ratio of the Mineral Rent(as % of GDP) of Oil in Latin America(developing only) to that in Lower middle income?
Offer a very short reply. 0.31. What is the ratio of the Mineral Rent(as % of GDP) of Other Minerals in Latin America(developing only) to that in Lower middle income?
Provide a short and direct response. 0.79. What is the ratio of the Mineral Rent(as % of GDP) in Coal in Latin America(developing only) to that in Middle East & North Africa (all income levels)?
Offer a terse response. 0.02. What is the ratio of the Mineral Rent(as % of GDP) of Natural Gas in Latin America(developing only) to that in Middle East & North Africa (all income levels)?
Give a very brief answer. 0.3. What is the ratio of the Mineral Rent(as % of GDP) of Oil in Latin America(developing only) to that in Middle East & North Africa (all income levels)?
Your answer should be compact. 0.03. What is the ratio of the Mineral Rent(as % of GDP) of Other Minerals in Latin America(developing only) to that in Middle East & North Africa (all income levels)?
Your answer should be compact. 8.79. What is the ratio of the Mineral Rent(as % of GDP) of Coal in Low & middle income to that in Lower middle income?
Offer a very short reply. 0.3. What is the ratio of the Mineral Rent(as % of GDP) in Natural Gas in Low & middle income to that in Lower middle income?
Provide a succinct answer. 1.84. What is the ratio of the Mineral Rent(as % of GDP) in Oil in Low & middle income to that in Lower middle income?
Provide a succinct answer. 1.21. What is the ratio of the Mineral Rent(as % of GDP) of Other Minerals in Low & middle income to that in Lower middle income?
Your response must be concise. 0.73. What is the ratio of the Mineral Rent(as % of GDP) of Coal in Low & middle income to that in Middle East & North Africa (all income levels)?
Give a very brief answer. 9.35. What is the ratio of the Mineral Rent(as % of GDP) of Natural Gas in Low & middle income to that in Middle East & North Africa (all income levels)?
Provide a succinct answer. 0.27. What is the ratio of the Mineral Rent(as % of GDP) of Oil in Low & middle income to that in Middle East & North Africa (all income levels)?
Ensure brevity in your answer.  0.11. What is the ratio of the Mineral Rent(as % of GDP) in Other Minerals in Low & middle income to that in Middle East & North Africa (all income levels)?
Offer a very short reply. 8.14. What is the ratio of the Mineral Rent(as % of GDP) in Coal in Lower middle income to that in Middle East & North Africa (all income levels)?
Your answer should be very brief. 31.03. What is the ratio of the Mineral Rent(as % of GDP) in Natural Gas in Lower middle income to that in Middle East & North Africa (all income levels)?
Ensure brevity in your answer.  0.14. What is the ratio of the Mineral Rent(as % of GDP) of Oil in Lower middle income to that in Middle East & North Africa (all income levels)?
Provide a succinct answer. 0.09. What is the ratio of the Mineral Rent(as % of GDP) in Other Minerals in Lower middle income to that in Middle East & North Africa (all income levels)?
Offer a terse response. 11.12. What is the difference between the highest and the second highest Mineral Rent(as % of GDP) of Coal?
Offer a terse response. 0.04. What is the difference between the highest and the second highest Mineral Rent(as % of GDP) in Natural Gas?
Keep it short and to the point. 0.25. What is the difference between the highest and the second highest Mineral Rent(as % of GDP) in Oil?
Your answer should be compact. 19.27. What is the difference between the highest and the second highest Mineral Rent(as % of GDP) of Other Minerals?
Your response must be concise. 0.07. What is the difference between the highest and the lowest Mineral Rent(as % of GDP) in Coal?
Provide a short and direct response. 0.05. What is the difference between the highest and the lowest Mineral Rent(as % of GDP) in Natural Gas?
Your answer should be very brief. 0.37. What is the difference between the highest and the lowest Mineral Rent(as % of GDP) of Oil?
Keep it short and to the point. 20.99. What is the difference between the highest and the lowest Mineral Rent(as % of GDP) of Other Minerals?
Make the answer very short. 0.92. 